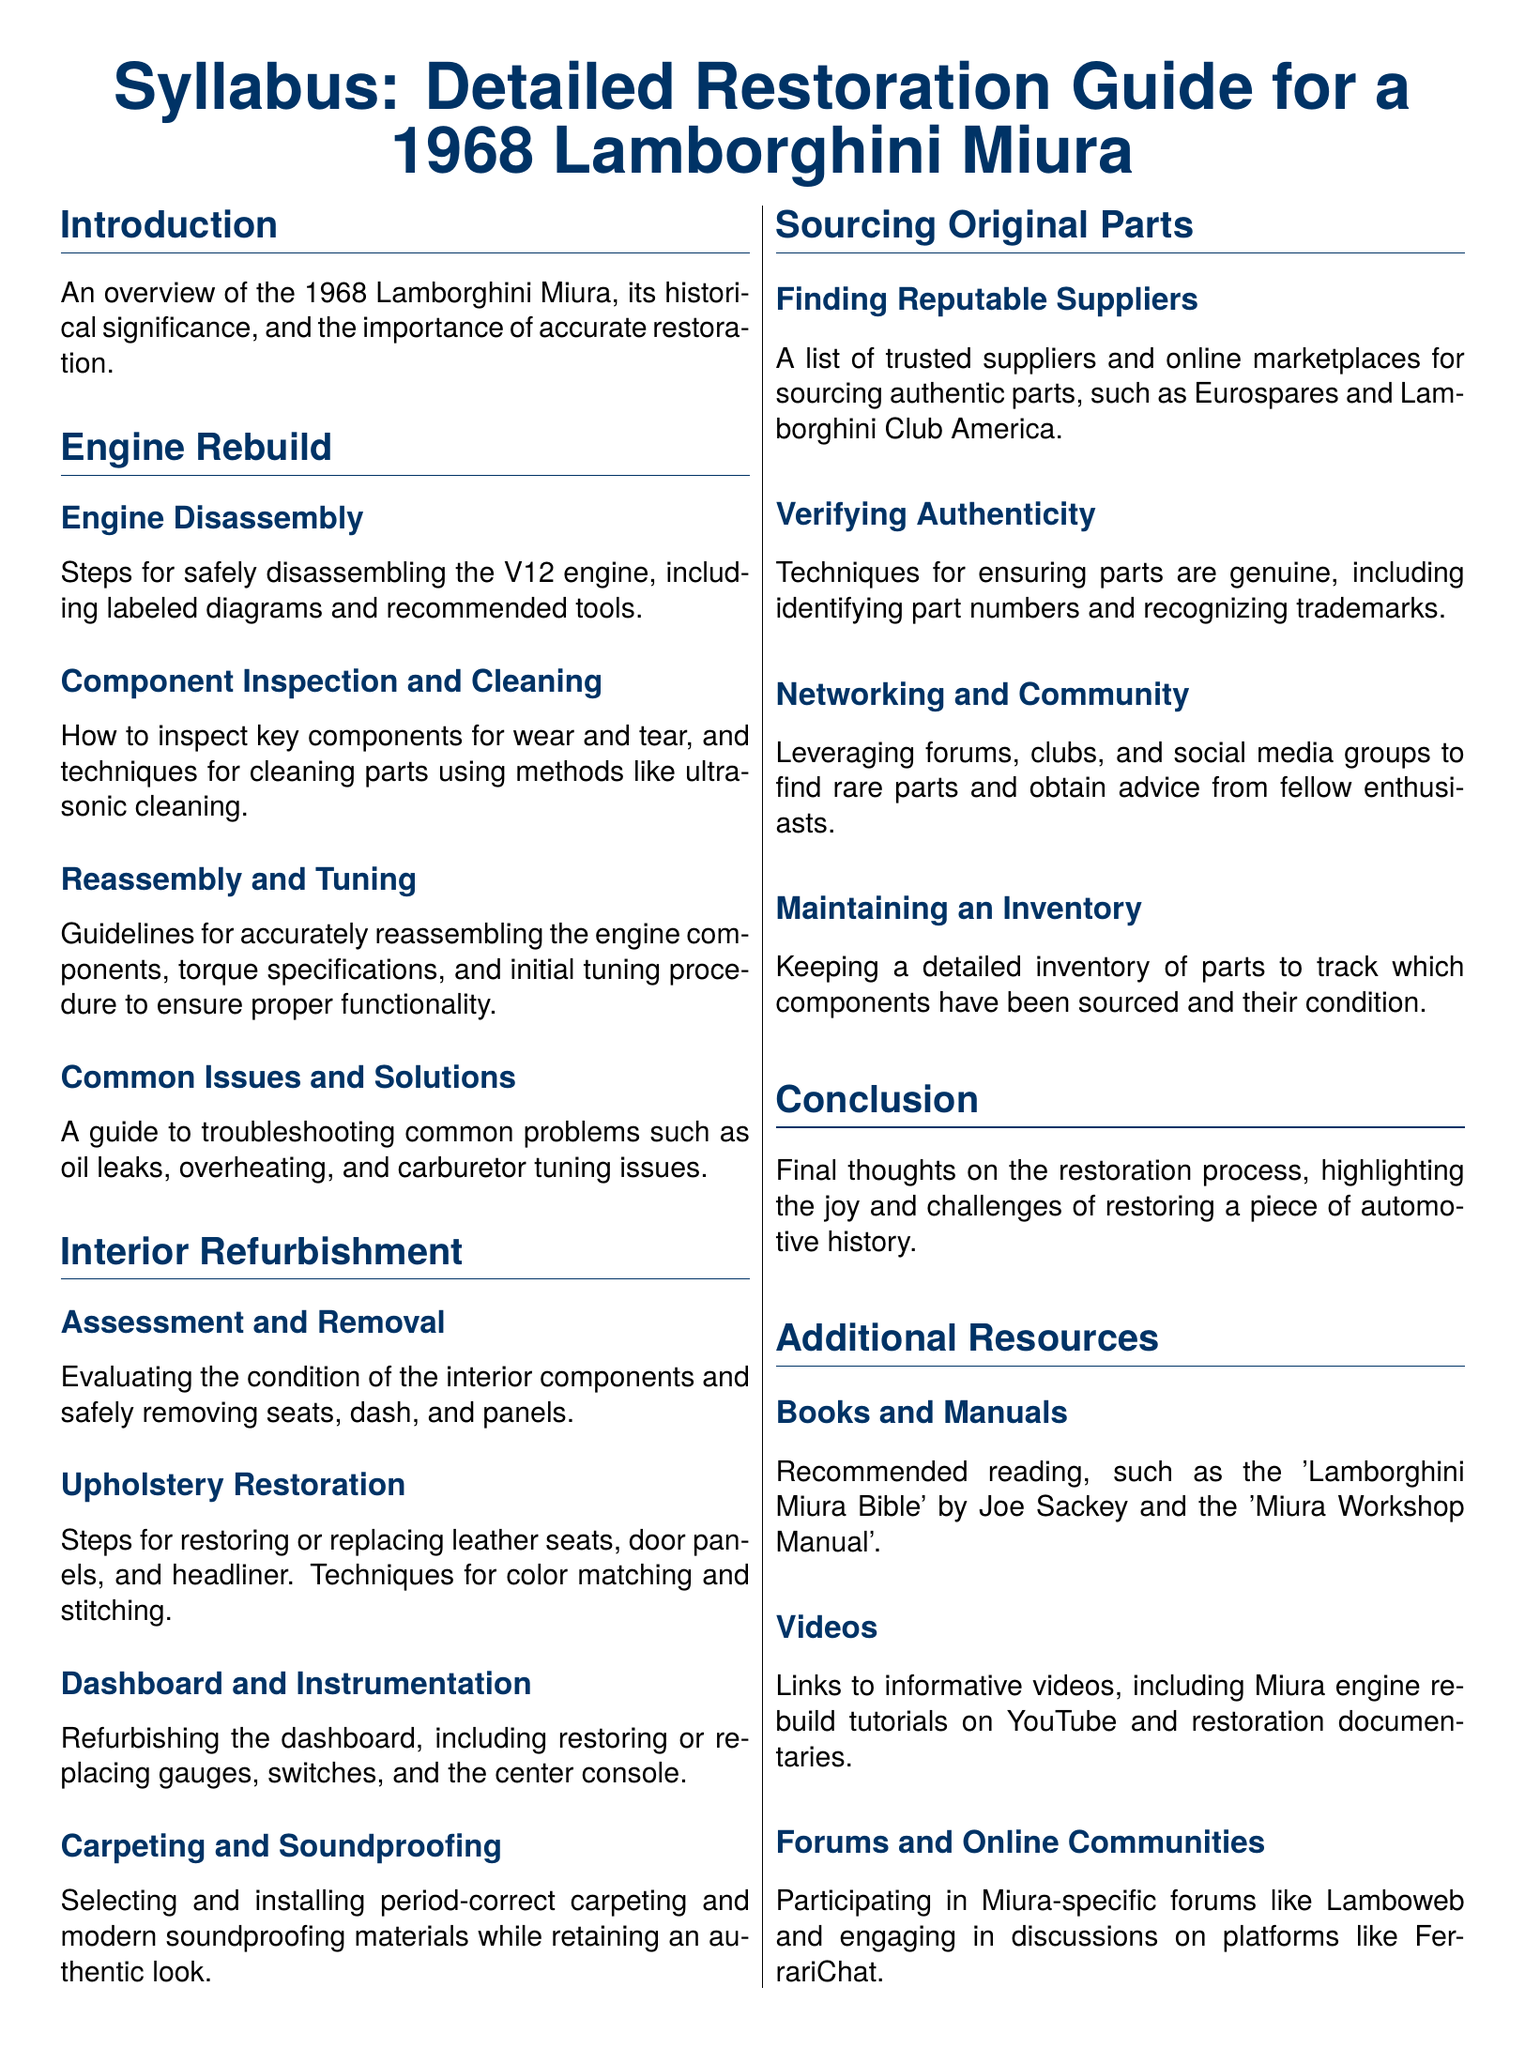What is the historical significance of the 1968 Lamborghini Miura? The document mentions that the introduction provides an overview of the Miura's historical significance that is discussed before diving into the restoration details.
Answer: Historical significance How many subsections are there in the Engine Rebuild section? The Engine Rebuild section contains four subsections: Engine Disassembly, Component Inspection and Cleaning, Reassembly and Tuning, and Common Issues and Solutions.
Answer: Four What is the purpose of ultrasonic cleaning in the restoration process? The document states that one of the techniques for cleaning parts is ultrasonic cleaning used in the Component Inspection and Cleaning subsection.
Answer: Cleaning parts Which part of the interior is assessed and removed for refurbishment? The Interior Refurbishment section includes evaluation and removal of various components as part of the refurbishment process, specifically mentioned as seats, dash, and panels.
Answer: Seats, dash, and panels What is a reliable source for sourcing authentic parts mentioned in the syllabus? The document lists Eurospares and Lamborghini Club America as trusted suppliers for sourcing original components in the Sourcing Original Parts section.
Answer: Eurospares What is the aim of the Networking and Community subsection? The aim is to leverage forums and clubs to find rare parts and obtain advice from fellow enthusiasts, which is outlined in the Sourcing Original Parts section.
Answer: Find rare parts How does the syllabus suggest you maintain an inventory? The document specifies that you should keep a detailed inventory of parts to track sourced components and their condition listed under the Sourcing Original Parts section.
Answer: Detailed inventory What is the title of the recommended reading book mentioned in Additional Resources? The syllabus suggests 'Lamborghini Miura Bible' by Joe Sackey as a reading recommendation under Additional Resources.
Answer: Lamborghini Miura Bible 